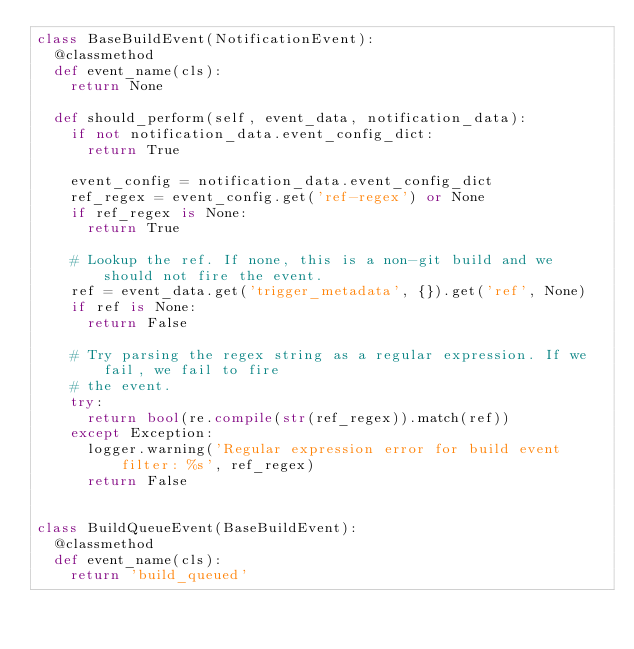Convert code to text. <code><loc_0><loc_0><loc_500><loc_500><_Python_>class BaseBuildEvent(NotificationEvent):
  @classmethod
  def event_name(cls):
    return None

  def should_perform(self, event_data, notification_data):
    if not notification_data.event_config_dict:
      return True

    event_config = notification_data.event_config_dict
    ref_regex = event_config.get('ref-regex') or None
    if ref_regex is None:
      return True

    # Lookup the ref. If none, this is a non-git build and we should not fire the event.
    ref = event_data.get('trigger_metadata', {}).get('ref', None)
    if ref is None:
      return False

    # Try parsing the regex string as a regular expression. If we fail, we fail to fire
    # the event.
    try:
      return bool(re.compile(str(ref_regex)).match(ref))
    except Exception:
      logger.warning('Regular expression error for build event filter: %s', ref_regex)
      return False


class BuildQueueEvent(BaseBuildEvent):
  @classmethod
  def event_name(cls):
    return 'build_queued'
</code> 